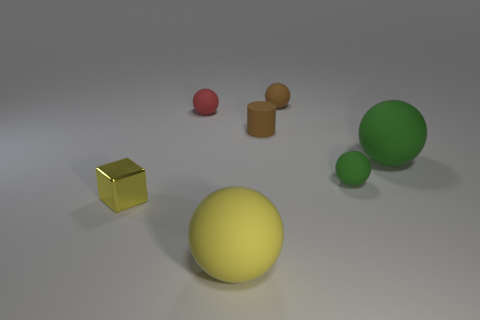Add 2 blue balls. How many objects exist? 9 Subtract all green cylinders. Subtract all brown spheres. How many cylinders are left? 1 Subtract all blocks. How many objects are left? 6 Add 5 yellow metal things. How many yellow metal things are left? 6 Add 1 matte cylinders. How many matte cylinders exist? 2 Subtract 0 green blocks. How many objects are left? 7 Subtract all brown rubber spheres. Subtract all matte things. How many objects are left? 0 